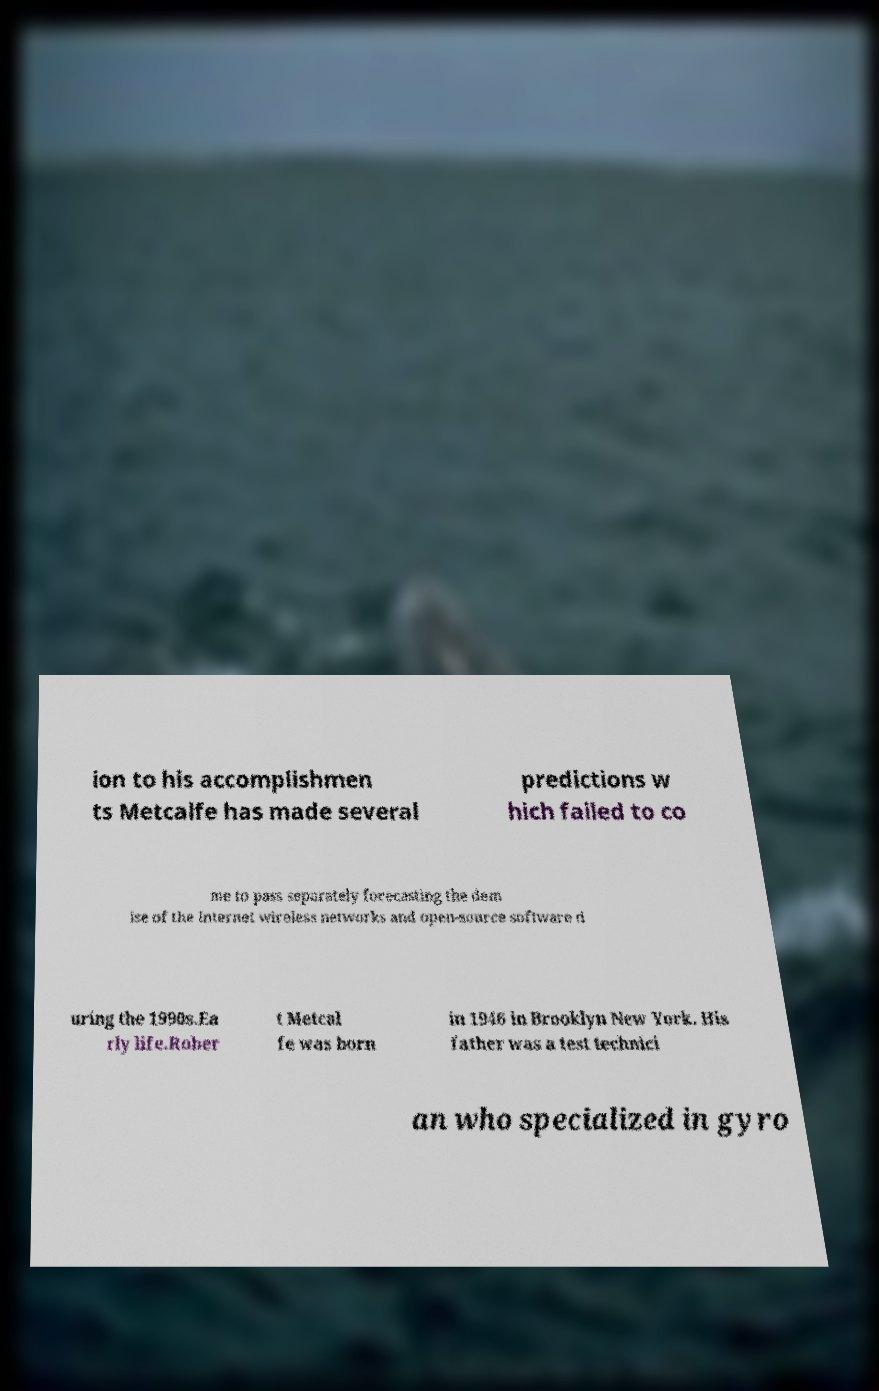Please identify and transcribe the text found in this image. ion to his accomplishmen ts Metcalfe has made several predictions w hich failed to co me to pass separately forecasting the dem ise of the Internet wireless networks and open-source software d uring the 1990s.Ea rly life.Rober t Metcal fe was born in 1946 in Brooklyn New York. His father was a test technici an who specialized in gyro 